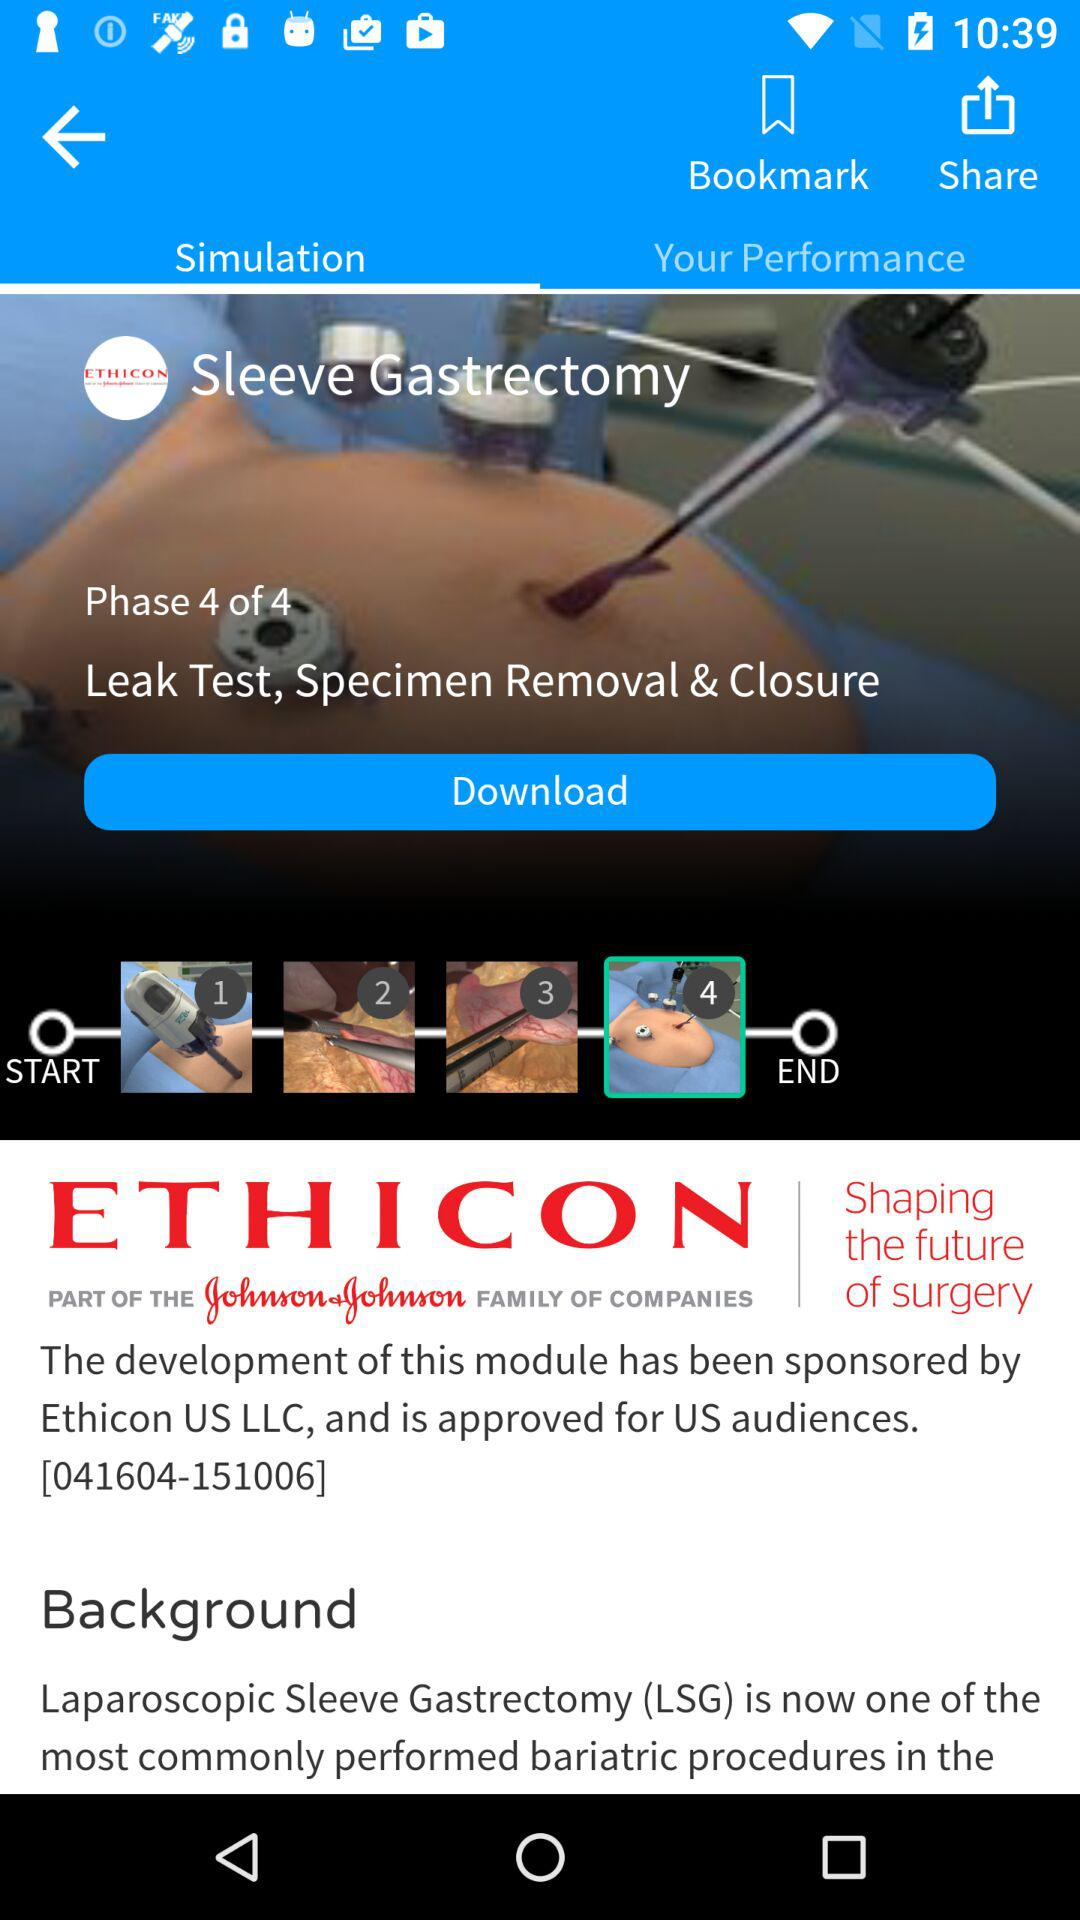Who is the sponsor of the module? The sponsor of the module is "Ethicon US LLC". 